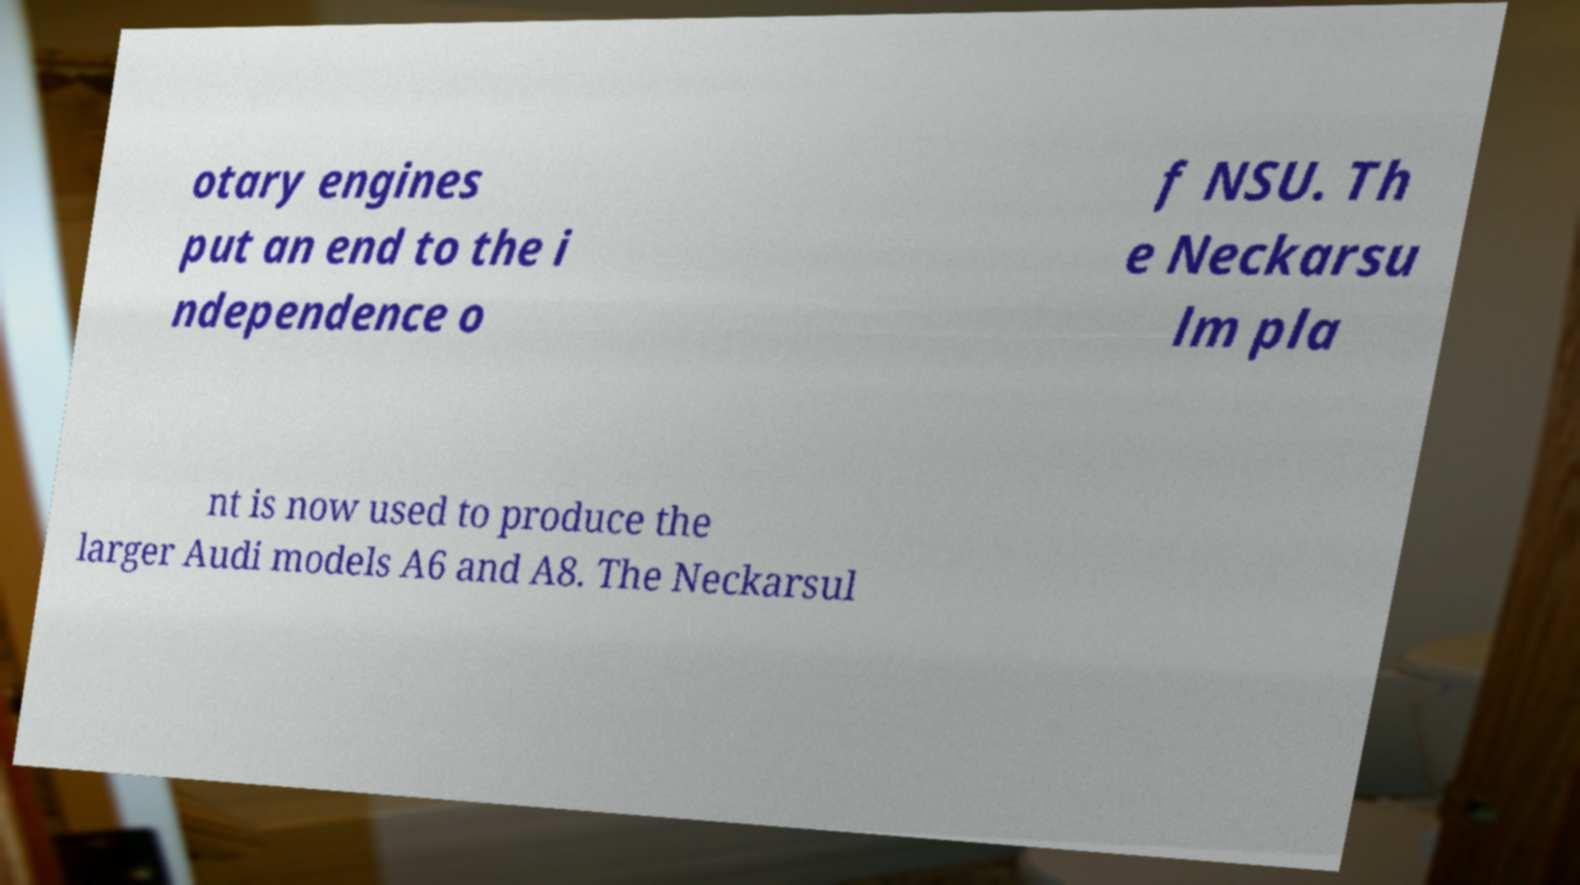There's text embedded in this image that I need extracted. Can you transcribe it verbatim? otary engines put an end to the i ndependence o f NSU. Th e Neckarsu lm pla nt is now used to produce the larger Audi models A6 and A8. The Neckarsul 